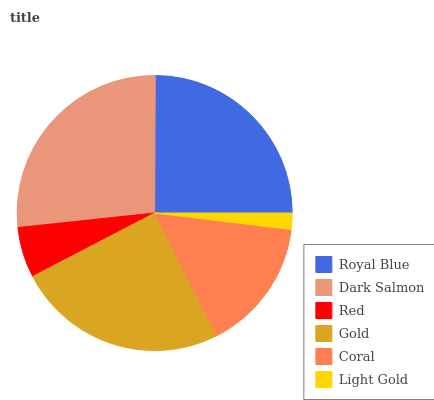Is Light Gold the minimum?
Answer yes or no. Yes. Is Dark Salmon the maximum?
Answer yes or no. Yes. Is Red the minimum?
Answer yes or no. No. Is Red the maximum?
Answer yes or no. No. Is Dark Salmon greater than Red?
Answer yes or no. Yes. Is Red less than Dark Salmon?
Answer yes or no. Yes. Is Red greater than Dark Salmon?
Answer yes or no. No. Is Dark Salmon less than Red?
Answer yes or no. No. Is Gold the high median?
Answer yes or no. Yes. Is Coral the low median?
Answer yes or no. Yes. Is Royal Blue the high median?
Answer yes or no. No. Is Gold the low median?
Answer yes or no. No. 